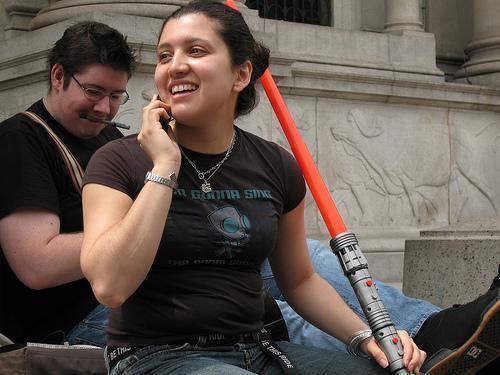How many females are wearing black shirts?
Give a very brief answer. 1. 